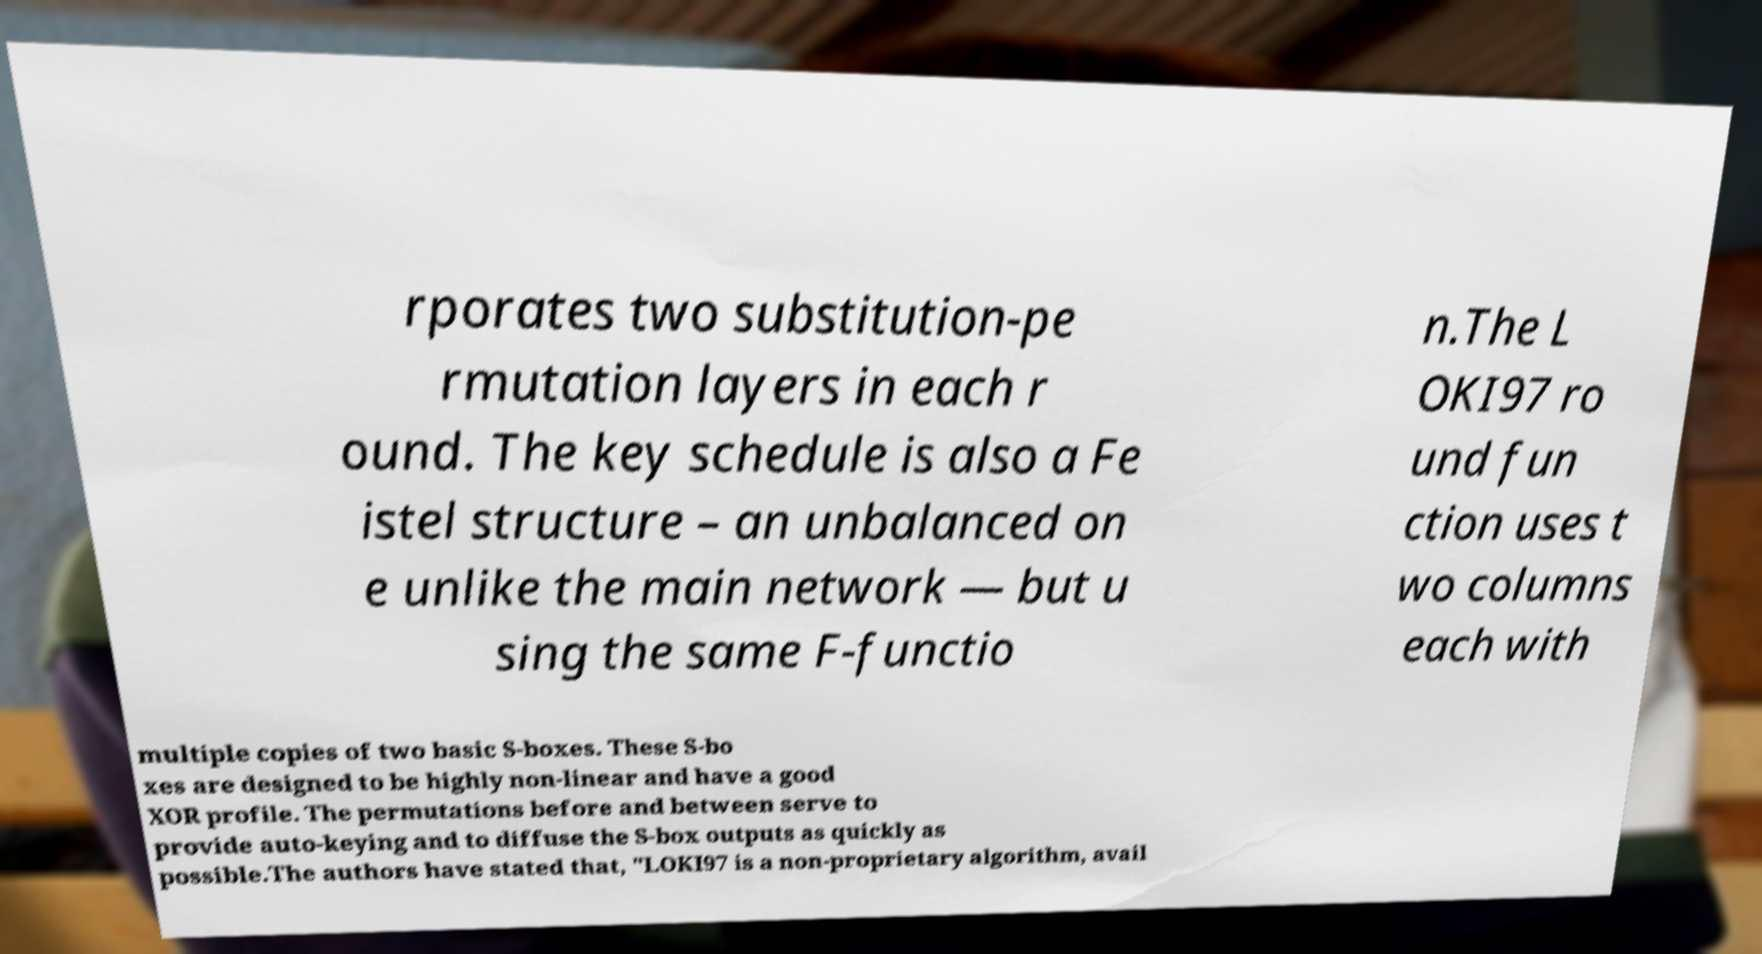Could you assist in decoding the text presented in this image and type it out clearly? rporates two substitution-pe rmutation layers in each r ound. The key schedule is also a Fe istel structure – an unbalanced on e unlike the main network — but u sing the same F-functio n.The L OKI97 ro und fun ction uses t wo columns each with multiple copies of two basic S-boxes. These S-bo xes are designed to be highly non-linear and have a good XOR profile. The permutations before and between serve to provide auto-keying and to diffuse the S-box outputs as quickly as possible.The authors have stated that, "LOKI97 is a non-proprietary algorithm, avail 